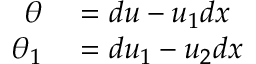<formula> <loc_0><loc_0><loc_500><loc_500>\begin{array} { r l } { \theta } & = d u - u _ { 1 } d x } \\ { \theta _ { 1 } } & = d u _ { 1 } - u _ { 2 } d x } \end{array}</formula> 